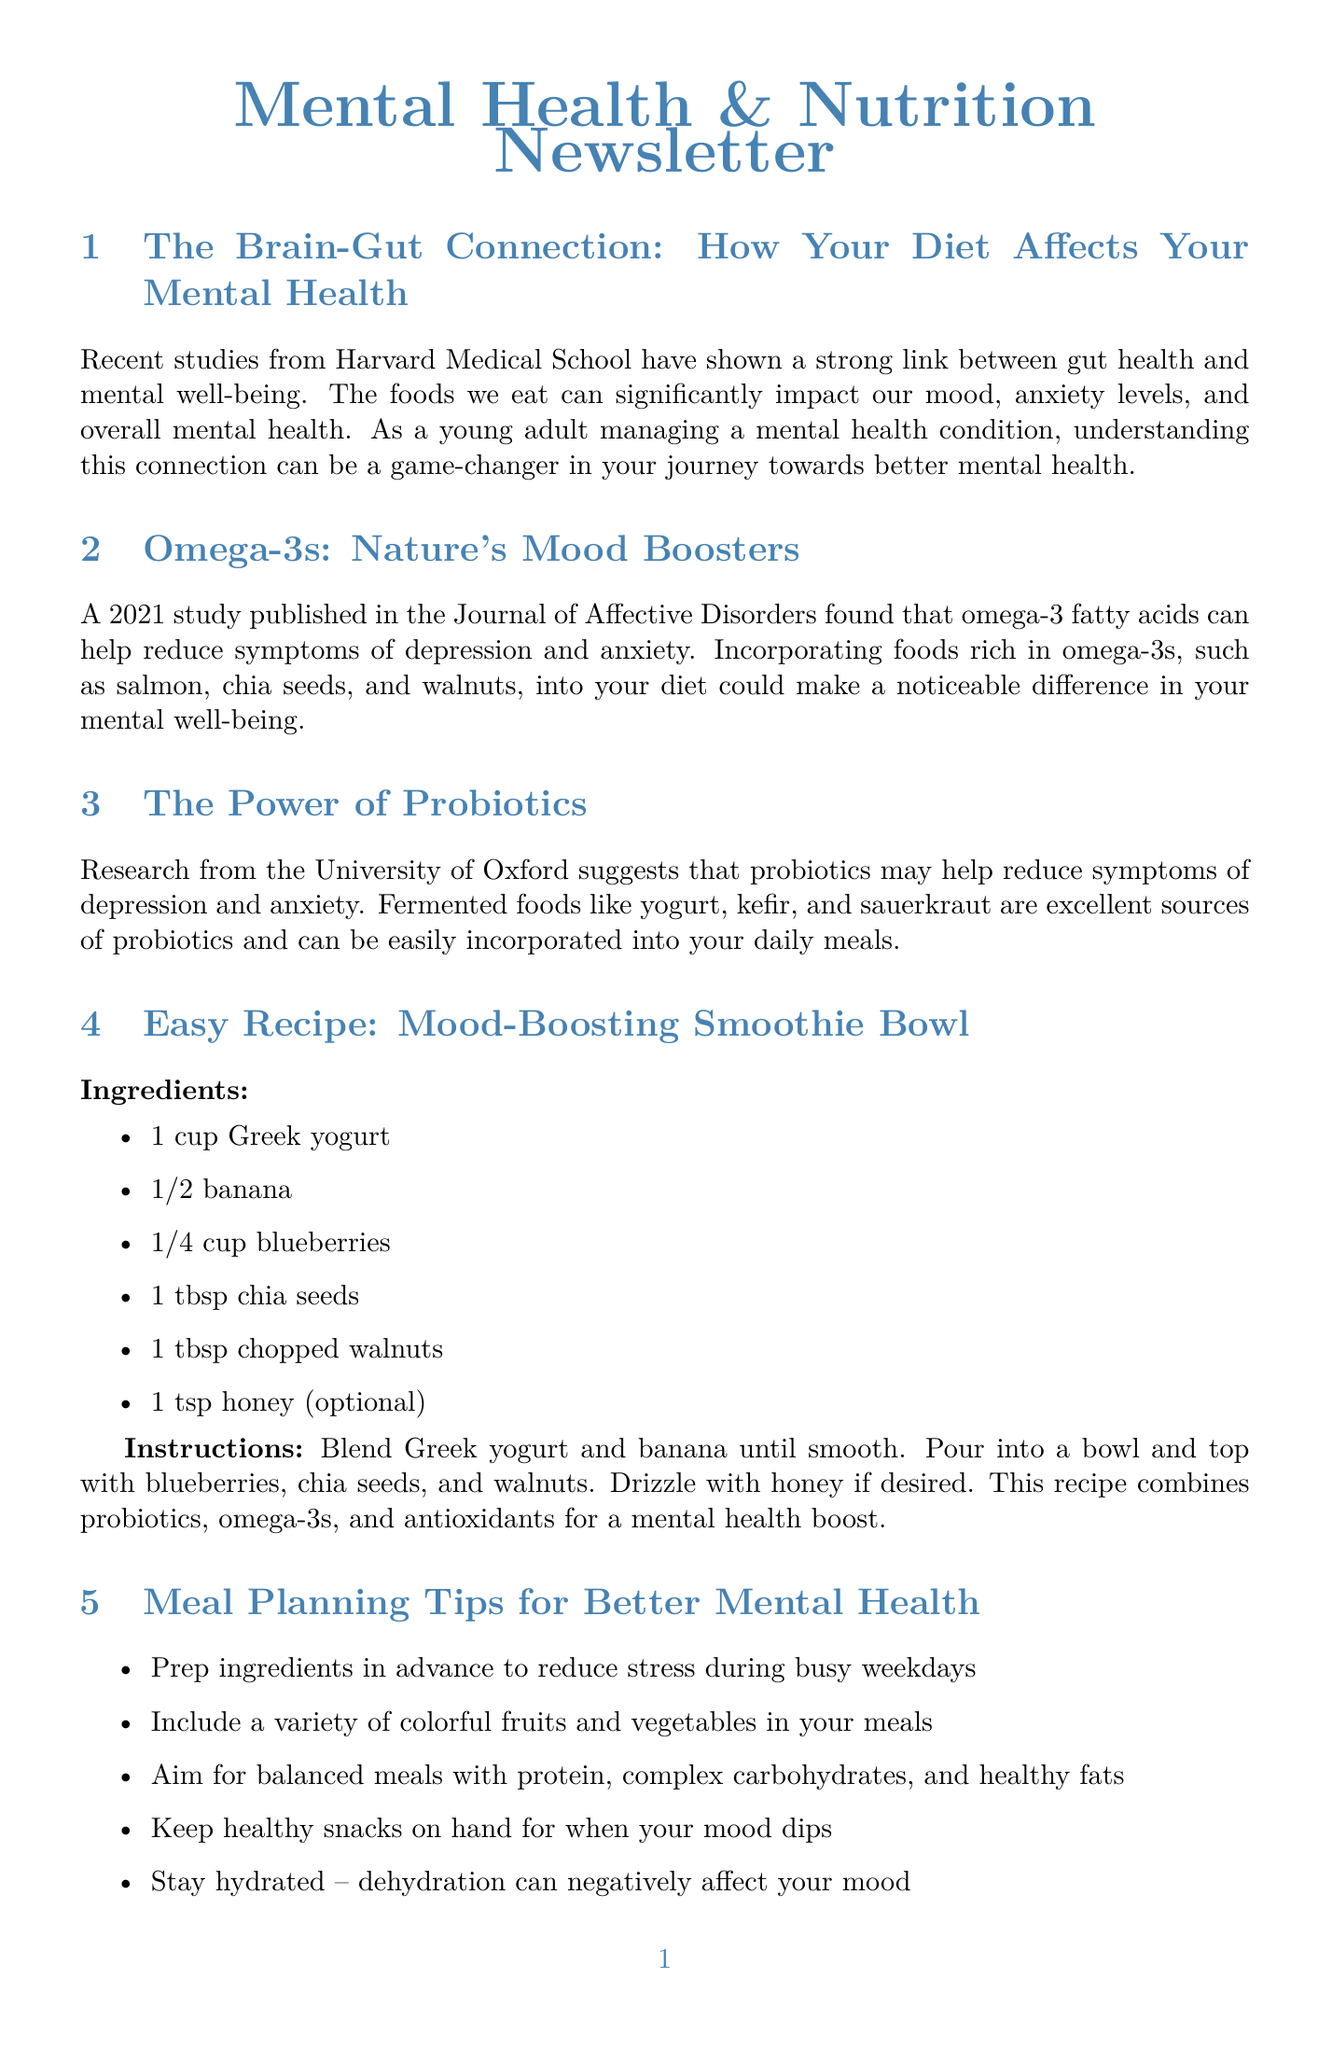What is the title of the first section? The title of the first section is given at the start of the content in the document.
Answer: The Brain-Gut Connection: How Your Diet Affects Your Mental Health Who conducted the studies linking gut health and mental well-being? The studies mentioned in the document about gut health and mental well-being are attributed to a specific institution.
Answer: Harvard Medical School What food is mentioned as rich in omega-3s? The document lists several foods that are rich in omega-3 fatty acids.
Answer: Salmon Name one fermented food that is a probiotic source. The document provides examples of fermented foods that help with mental health.
Answer: Yogurt What is the main focus of the "Mindful Eating" section? This section discusses a particular method of eating that positively impacts mental health.
Answer: Importance of mindful eating How many days are included in the weekly meal plan example? The weekly meal plan example outlines meals for a specific number of days.
Answer: Three What type of ingredient prep is recommended for better mental health? One tip in the meal planning section suggests a certain practice to alleviate stress during meal preparation.
Answer: Prep ingredients in advance What is the main ingredient in the Mood-Boosting Smoothie Bowl? The recipe lists a primary ingredient that forms the base of the smoothie bowl.
Answer: Greek yogurt 